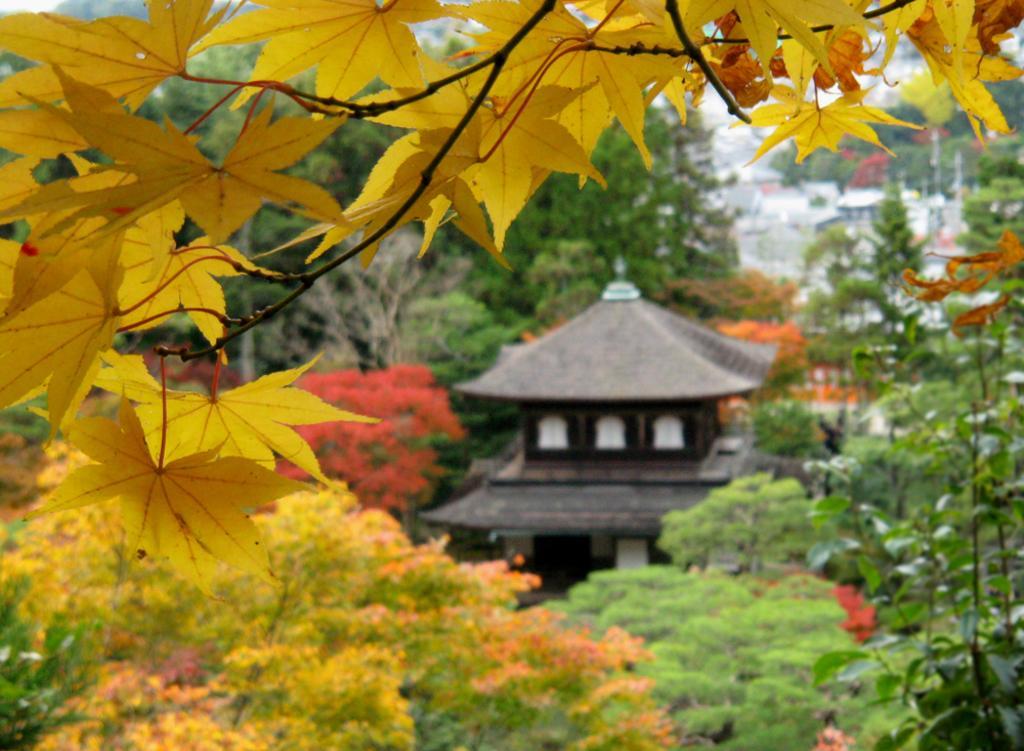Can you describe this image briefly? In the image there are yellow leaves to the branch of a tree and behind that tree there are many other trees and in between the trees there is some architecture. 